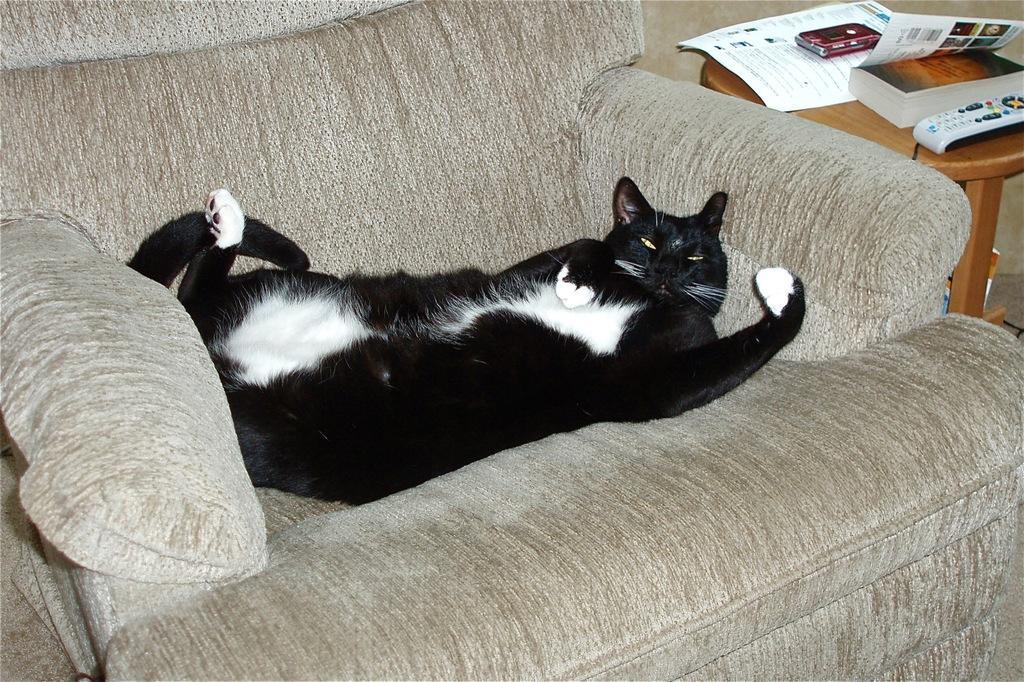In one or two sentences, can you explain what this image depicts? In the image there is a couch. On couch we can see a cat lying, on right side there is a table. On table we can see a remote,book,wallet and a paper. 